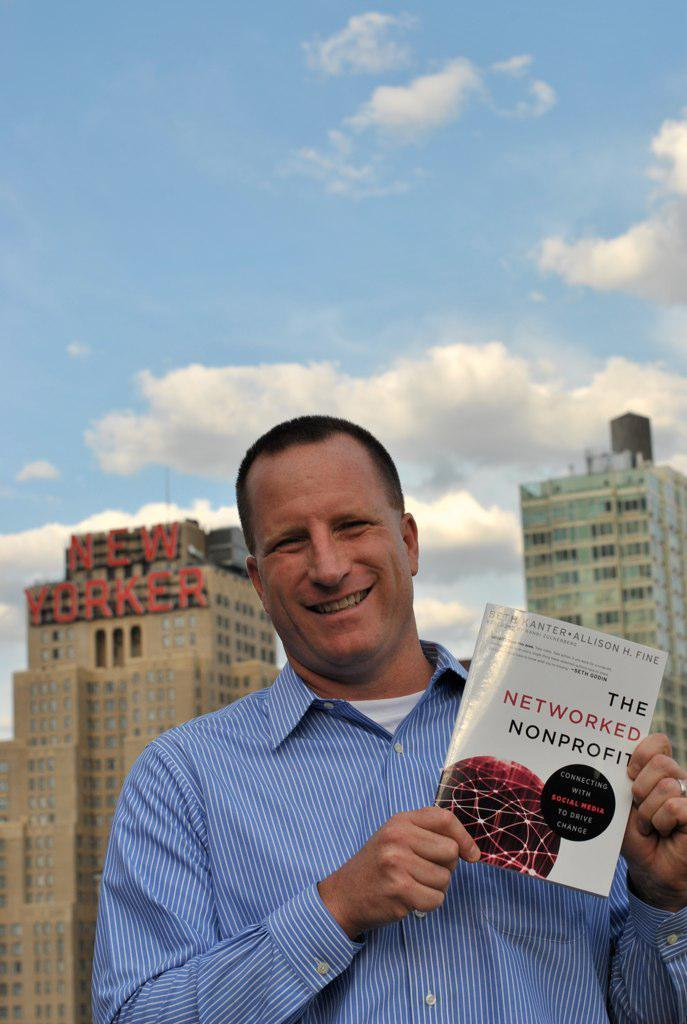Provide a one-sentence caption for the provided image. A business man in front of the new yorker building holding a book titled the networked nonprofit. 